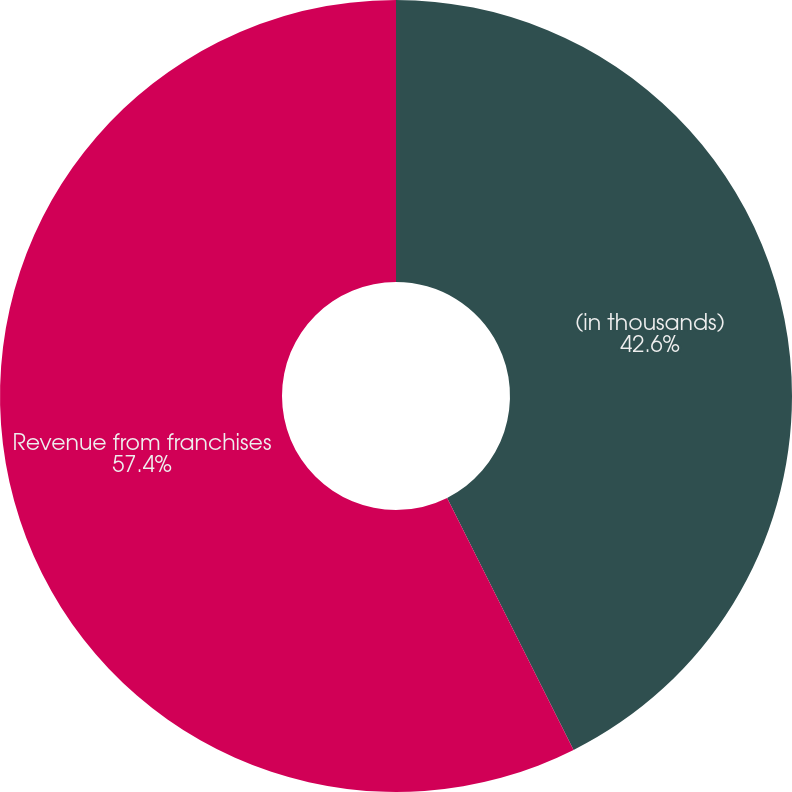Convert chart to OTSL. <chart><loc_0><loc_0><loc_500><loc_500><pie_chart><fcel>(in thousands)<fcel>Revenue from franchises<nl><fcel>42.6%<fcel>57.4%<nl></chart> 